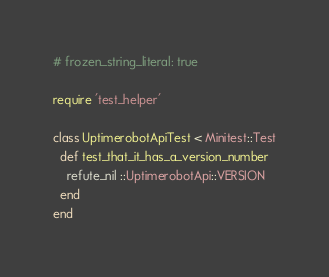Convert code to text. <code><loc_0><loc_0><loc_500><loc_500><_Ruby_># frozen_string_literal: true

require 'test_helper'

class UptimerobotApiTest < Minitest::Test
  def test_that_it_has_a_version_number
    refute_nil ::UptimerobotApi::VERSION
  end
end
</code> 